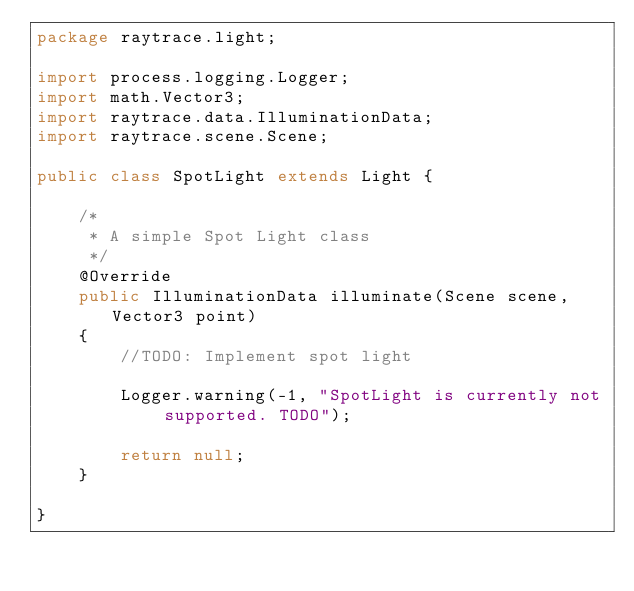<code> <loc_0><loc_0><loc_500><loc_500><_Java_>package raytrace.light;

import process.logging.Logger;
import math.Vector3;
import raytrace.data.IlluminationData;
import raytrace.scene.Scene;

public class SpotLight extends Light {

	/*
	 * A simple Spot Light class
	 */
	@Override
	public IlluminationData illuminate(Scene scene, Vector3 point)
	{
		//TODO: Implement spot light
		
		Logger.warning(-1, "SpotLight is currently not supported. TODO");
		
		return null;
	}

}
</code> 